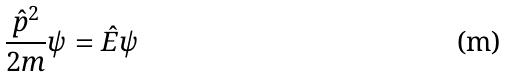<formula> <loc_0><loc_0><loc_500><loc_500>\frac { \hat { p } ^ { 2 } } { 2 m } \psi = \hat { E } \psi</formula> 